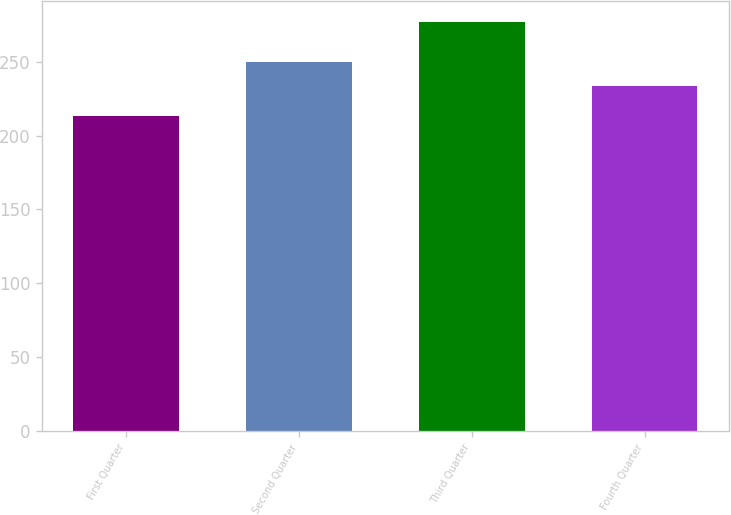Convert chart to OTSL. <chart><loc_0><loc_0><loc_500><loc_500><bar_chart><fcel>First Quarter<fcel>Second Quarter<fcel>Third Quarter<fcel>Fourth Quarter<nl><fcel>213.06<fcel>249.58<fcel>277.26<fcel>233.82<nl></chart> 